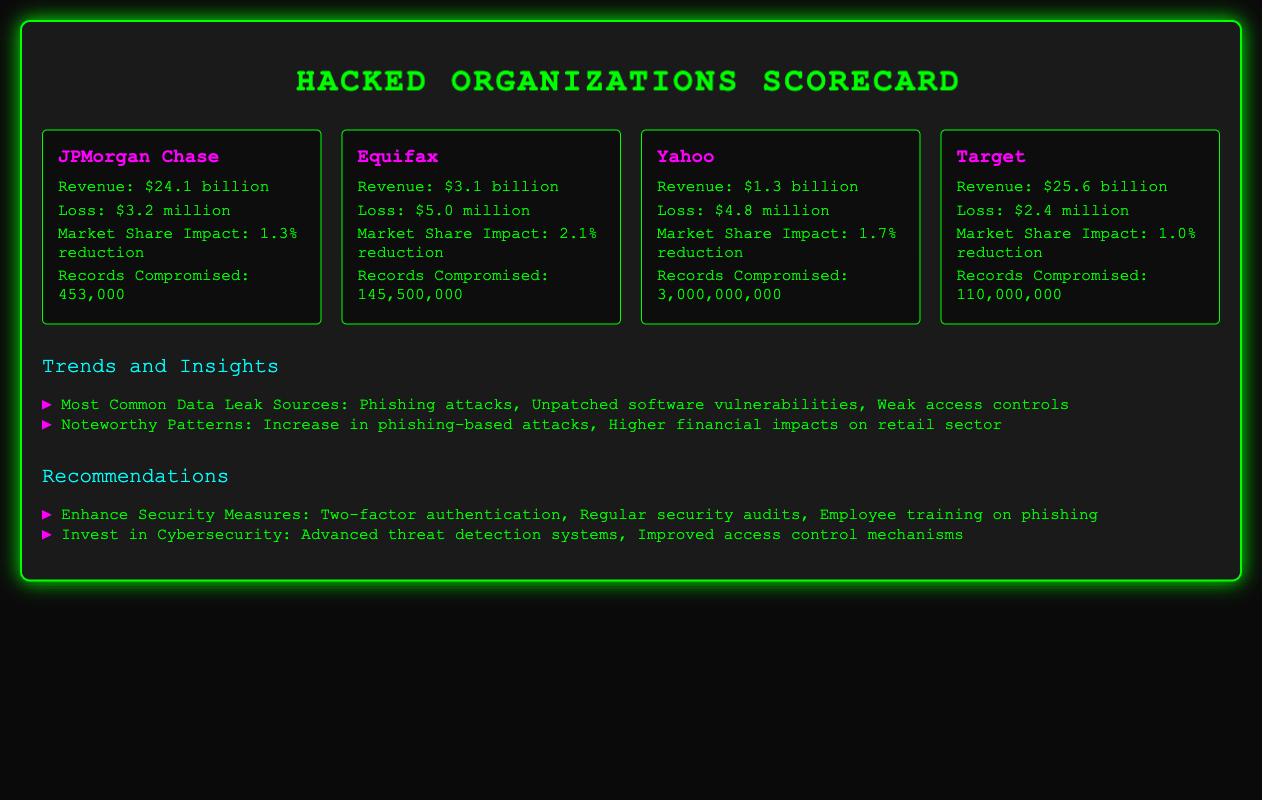what is the revenue of JPMorgan Chase? The revenue listed for JPMorgan Chase in the document is $24.1 billion.
Answer: $24.1 billion how many records were compromised by Yahoo? The document states that Yahoo had 3,000,000,000 records compromised.
Answer: 3,000,000,000 what was the market share impact for Equifax? The document indicates that Equifax experienced a 2.1% reduction in market share.
Answer: 2.1% reduction which organization had the highest financial loss? Reviewing the losses for each organization, Equifax had the highest loss at $5.0 million.
Answer: Equifax what is a common data leak source mentioned in the trends and insights? The document lists phishing attacks as one of the most common data leak sources.
Answer: Phishing attacks how many records were compromised by Target? According to the document, Target had 110,000,000 records compromised.
Answer: 110,000,000 what is one recommended security measure? The document recommends implementing two-factor authentication as a security measure.
Answer: Two-factor authentication which organization had the lowest revenue? The document shows that Yahoo had the lowest revenue at $1.3 billion.
Answer: Yahoo what is noted as a noteworthy pattern in the report? A noteworthy pattern mentioned is the increase in phishing-based attacks.
Answer: Increase in phishing-based attacks 